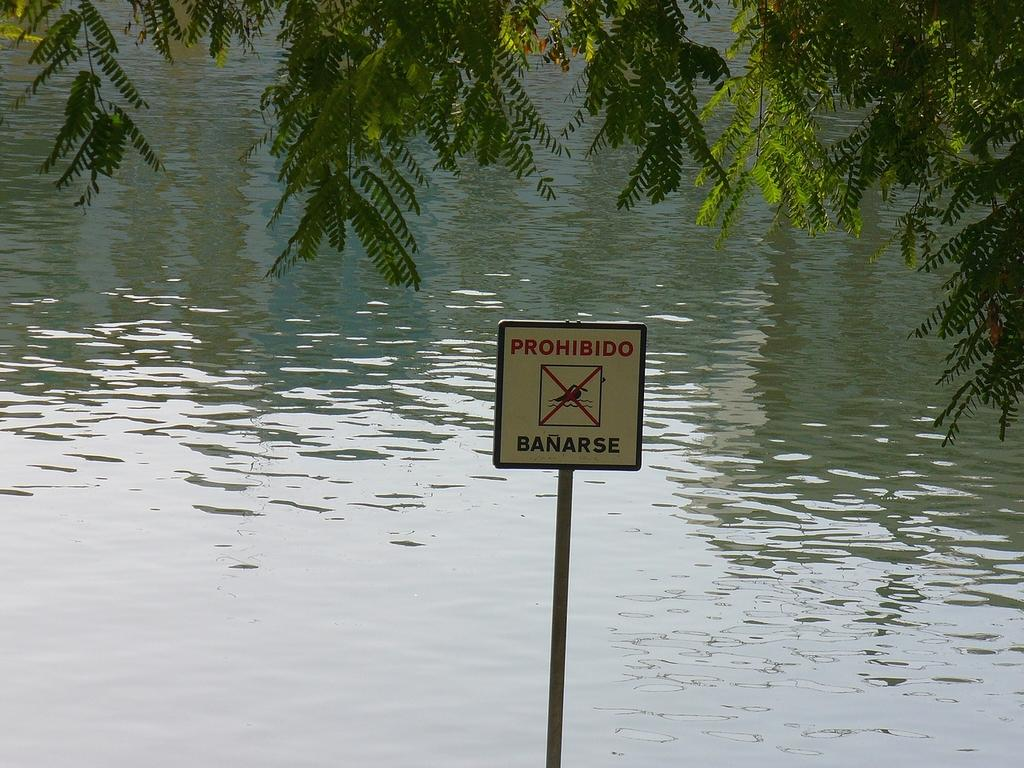What is displayed on the signboard in the image? There is a signboard with text in the image, but the specific text cannot be determined from the facts provided. What type of vegetation can be seen in the image? There are branches of a tree visible in the image. What natural feature is present in the image? There is a water body in the image. How does the horse interact with the signboard in the image? There is no horse present in the image, so it cannot interact with the signboard. 